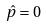Convert formula to latex. <formula><loc_0><loc_0><loc_500><loc_500>\hat { p } = 0</formula> 